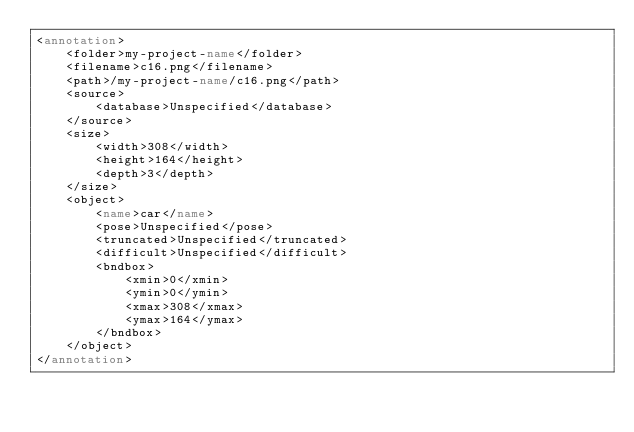<code> <loc_0><loc_0><loc_500><loc_500><_XML_><annotation>
	<folder>my-project-name</folder>
	<filename>c16.png</filename>
	<path>/my-project-name/c16.png</path>
	<source>
		<database>Unspecified</database>
	</source>
	<size>
		<width>308</width>
		<height>164</height>
		<depth>3</depth>
	</size>
	<object>
		<name>car</name>
		<pose>Unspecified</pose>
		<truncated>Unspecified</truncated>
		<difficult>Unspecified</difficult>
		<bndbox>
			<xmin>0</xmin>
			<ymin>0</ymin>
			<xmax>308</xmax>
			<ymax>164</ymax>
		</bndbox>
	</object>
</annotation></code> 